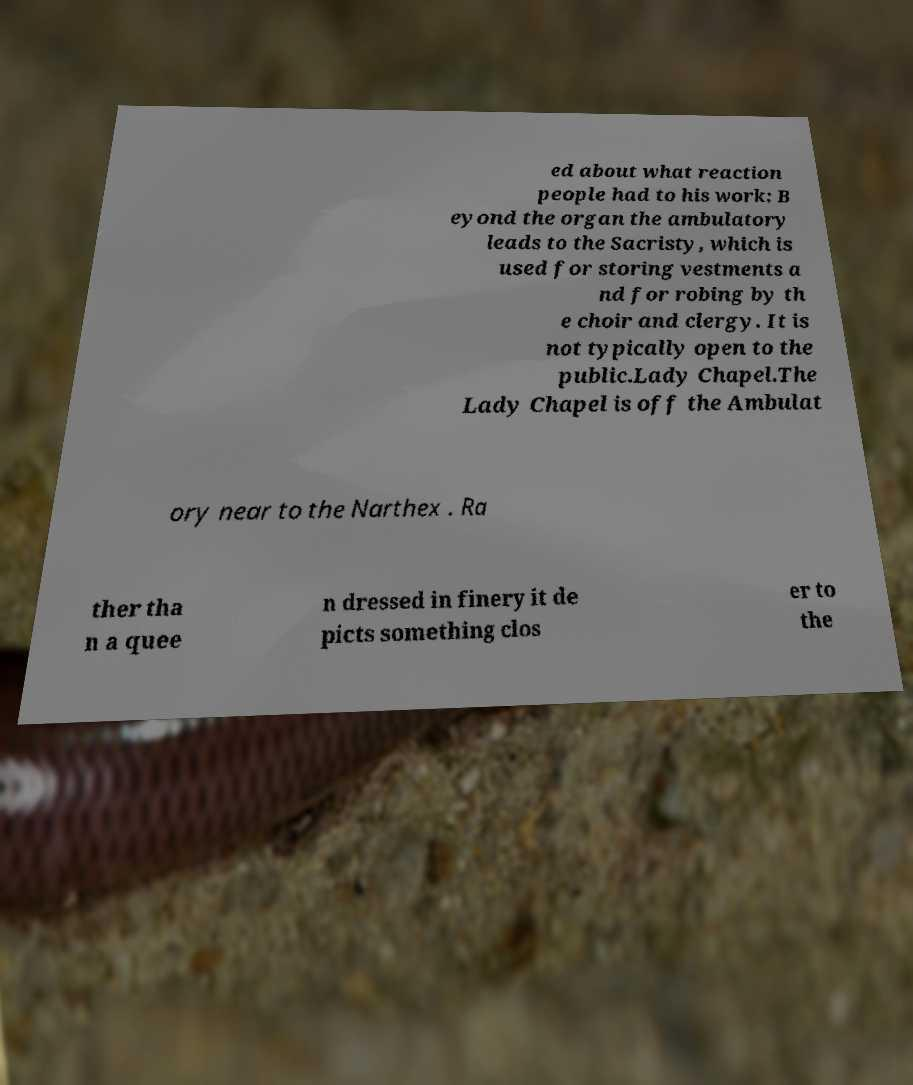Could you assist in decoding the text presented in this image and type it out clearly? ed about what reaction people had to his work: B eyond the organ the ambulatory leads to the Sacristy, which is used for storing vestments a nd for robing by th e choir and clergy. It is not typically open to the public.Lady Chapel.The Lady Chapel is off the Ambulat ory near to the Narthex . Ra ther tha n a quee n dressed in finery it de picts something clos er to the 